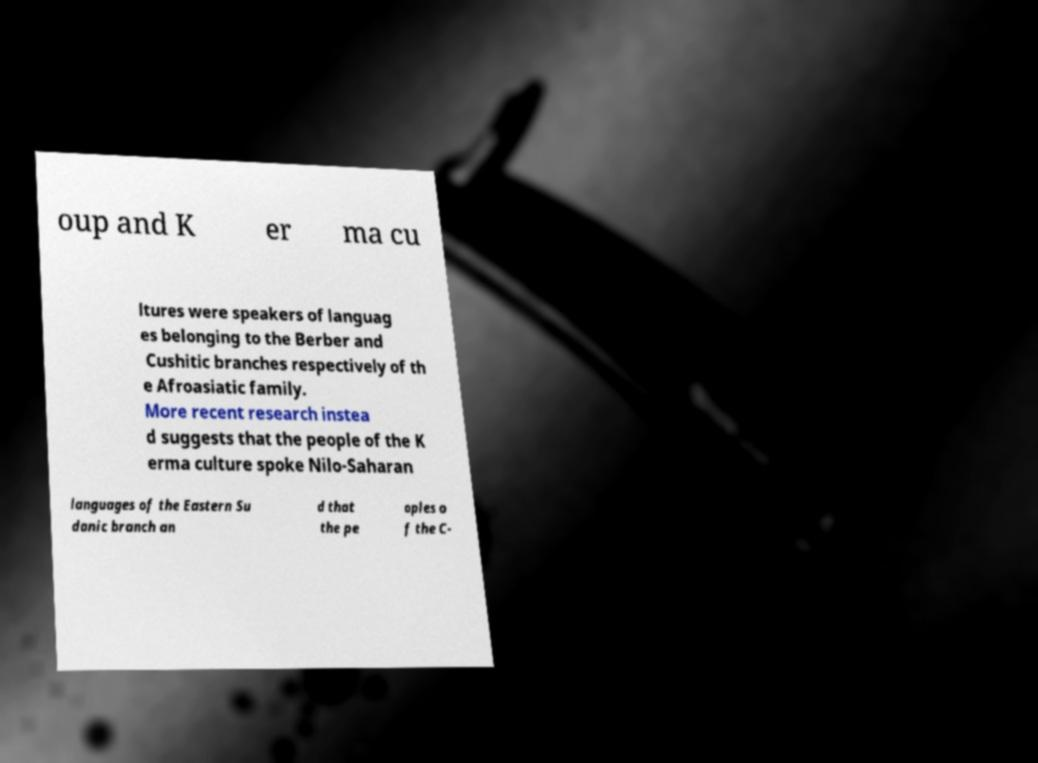Could you extract and type out the text from this image? oup and K er ma cu ltures were speakers of languag es belonging to the Berber and Cushitic branches respectively of th e Afroasiatic family. More recent research instea d suggests that the people of the K erma culture spoke Nilo-Saharan languages of the Eastern Su danic branch an d that the pe oples o f the C- 